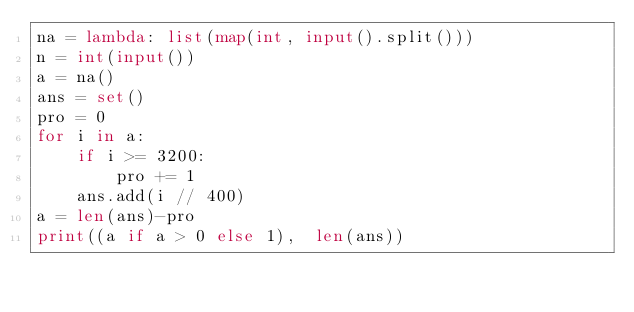<code> <loc_0><loc_0><loc_500><loc_500><_Python_>na = lambda: list(map(int, input().split()))
n = int(input())
a = na()
ans = set()
pro = 0
for i in a:
    if i >= 3200:
        pro += 1
    ans.add(i // 400)
a = len(ans)-pro
print((a if a > 0 else 1),  len(ans))</code> 